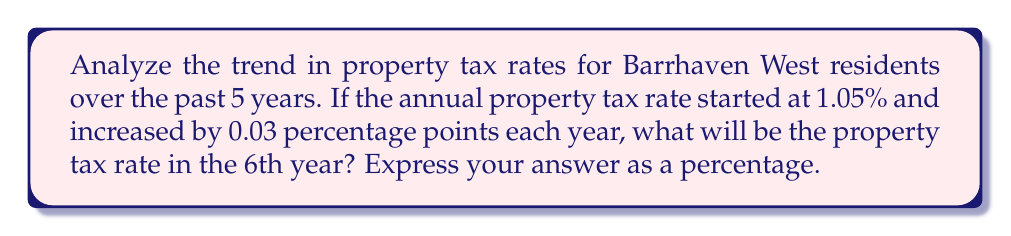Provide a solution to this math problem. Let's approach this step-by-step:

1) We start with the initial tax rate:
   Year 1: 1.05%

2) Each year, the rate increases by 0.03 percentage points. Let's calculate for the next 4 years:
   Year 2: $1.05\% + 0.03\% = 1.08\%$
   Year 3: $1.08\% + 0.03\% = 1.11\%$
   Year 4: $1.11\% + 0.03\% = 1.14\%$
   Year 5: $1.14\% + 0.03\% = 1.17\%$

3) To find the rate for the 6th year, we add 0.03% one more time:
   Year 6: $1.17\% + 0.03\% = 1.20\%$

4) Alternatively, we can use the arithmetic sequence formula:
   $a_n = a_1 + (n-1)d$
   Where $a_n$ is the nth term, $a_1$ is the first term, $n$ is the position of the term, and $d$ is the common difference.

   For the 6th year: $a_6 = 1.05\% + (6-1)(0.03\%) = 1.05\% + 0.15\% = 1.20\%$

Therefore, the property tax rate in the 6th year will be 1.20%.
Answer: 1.20% 